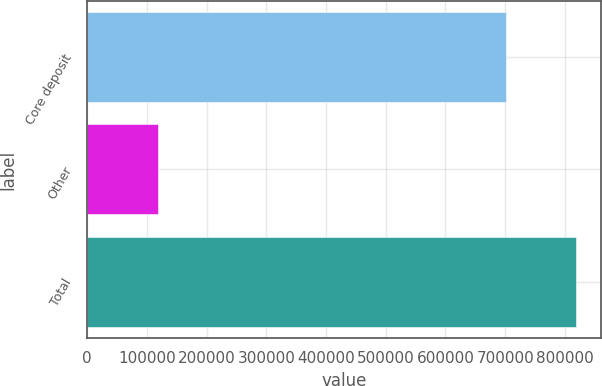Convert chart. <chart><loc_0><loc_0><loc_500><loc_500><bar_chart><fcel>Core deposit<fcel>Other<fcel>Total<nl><fcel>701000<fcel>118366<fcel>819366<nl></chart> 